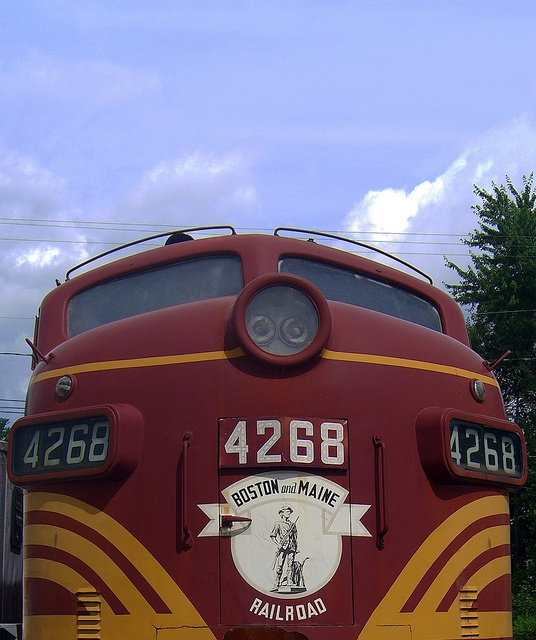Describe the objects in this image and their specific colors. I can see a train in lightblue, maroon, black, olive, and gray tones in this image. 